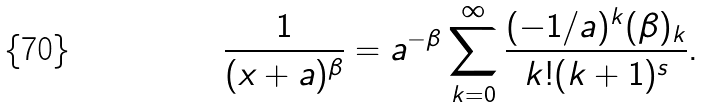Convert formula to latex. <formula><loc_0><loc_0><loc_500><loc_500>\frac { 1 } { ( x + a ) ^ { \beta } } = a ^ { - \beta } \sum _ { k = 0 } ^ { \infty } \frac { ( - 1 / a ) ^ { k } ( \beta ) _ { k } } { k ! ( k + 1 ) ^ { s } } .</formula> 